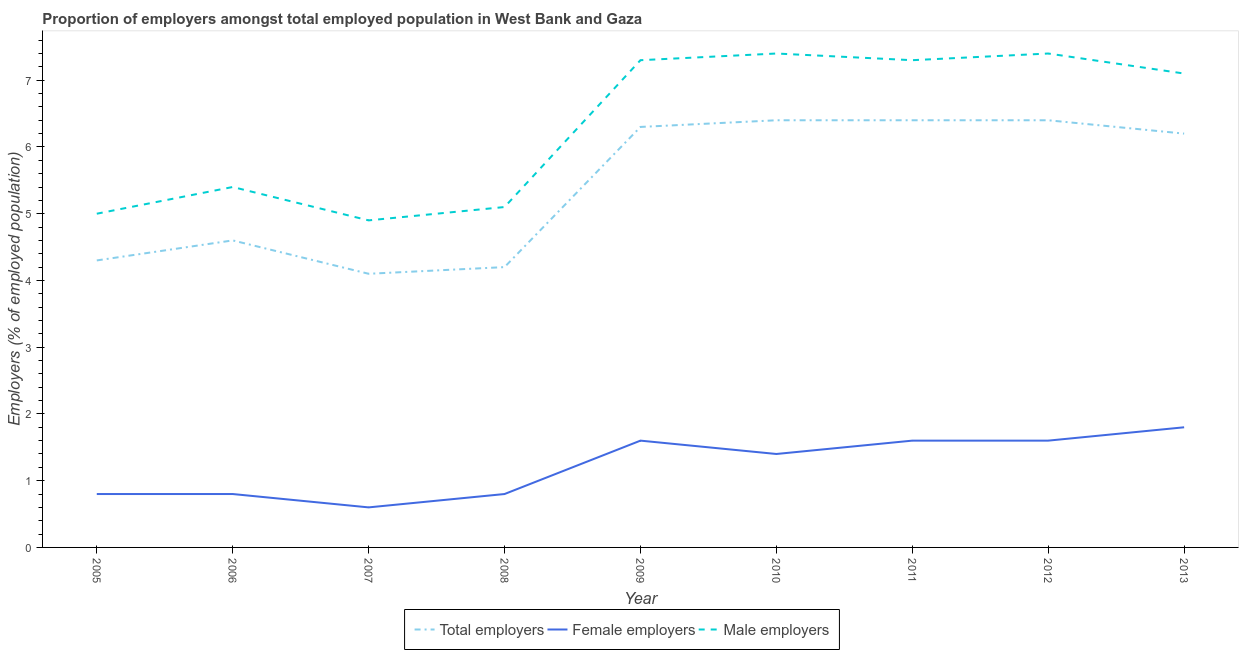Does the line corresponding to percentage of total employers intersect with the line corresponding to percentage of female employers?
Ensure brevity in your answer.  No. What is the percentage of male employers in 2005?
Keep it short and to the point. 5. Across all years, what is the maximum percentage of male employers?
Offer a terse response. 7.4. Across all years, what is the minimum percentage of female employers?
Your response must be concise. 0.6. In which year was the percentage of male employers maximum?
Ensure brevity in your answer.  2010. In which year was the percentage of female employers minimum?
Offer a terse response. 2007. What is the total percentage of male employers in the graph?
Make the answer very short. 56.9. What is the difference between the percentage of male employers in 2006 and that in 2007?
Provide a succinct answer. 0.5. What is the difference between the percentage of male employers in 2010 and the percentage of female employers in 2005?
Your response must be concise. 6.6. What is the average percentage of male employers per year?
Make the answer very short. 6.32. In the year 2011, what is the difference between the percentage of total employers and percentage of male employers?
Offer a very short reply. -0.9. In how many years, is the percentage of male employers greater than 5.8 %?
Ensure brevity in your answer.  5. What is the ratio of the percentage of female employers in 2005 to that in 2007?
Your answer should be compact. 1.33. Is the difference between the percentage of total employers in 2006 and 2011 greater than the difference between the percentage of male employers in 2006 and 2011?
Offer a very short reply. Yes. What is the difference between the highest and the lowest percentage of female employers?
Offer a terse response. 1.2. Is the sum of the percentage of total employers in 2010 and 2011 greater than the maximum percentage of female employers across all years?
Your answer should be very brief. Yes. Is it the case that in every year, the sum of the percentage of total employers and percentage of female employers is greater than the percentage of male employers?
Keep it short and to the point. No. Does the percentage of male employers monotonically increase over the years?
Keep it short and to the point. No. Is the percentage of female employers strictly less than the percentage of male employers over the years?
Give a very brief answer. Yes. How many lines are there?
Provide a succinct answer. 3. How many years are there in the graph?
Provide a short and direct response. 9. Does the graph contain grids?
Make the answer very short. No. Where does the legend appear in the graph?
Offer a very short reply. Bottom center. How are the legend labels stacked?
Ensure brevity in your answer.  Horizontal. What is the title of the graph?
Offer a very short reply. Proportion of employers amongst total employed population in West Bank and Gaza. Does "Renewable sources" appear as one of the legend labels in the graph?
Provide a short and direct response. No. What is the label or title of the Y-axis?
Your answer should be very brief. Employers (% of employed population). What is the Employers (% of employed population) of Total employers in 2005?
Keep it short and to the point. 4.3. What is the Employers (% of employed population) in Female employers in 2005?
Your response must be concise. 0.8. What is the Employers (% of employed population) in Male employers in 2005?
Ensure brevity in your answer.  5. What is the Employers (% of employed population) of Total employers in 2006?
Offer a terse response. 4.6. What is the Employers (% of employed population) in Female employers in 2006?
Your answer should be compact. 0.8. What is the Employers (% of employed population) in Male employers in 2006?
Make the answer very short. 5.4. What is the Employers (% of employed population) of Total employers in 2007?
Give a very brief answer. 4.1. What is the Employers (% of employed population) in Female employers in 2007?
Make the answer very short. 0.6. What is the Employers (% of employed population) in Male employers in 2007?
Offer a terse response. 4.9. What is the Employers (% of employed population) of Total employers in 2008?
Give a very brief answer. 4.2. What is the Employers (% of employed population) of Female employers in 2008?
Keep it short and to the point. 0.8. What is the Employers (% of employed population) of Male employers in 2008?
Your answer should be compact. 5.1. What is the Employers (% of employed population) in Total employers in 2009?
Offer a very short reply. 6.3. What is the Employers (% of employed population) of Female employers in 2009?
Your answer should be compact. 1.6. What is the Employers (% of employed population) in Male employers in 2009?
Ensure brevity in your answer.  7.3. What is the Employers (% of employed population) in Total employers in 2010?
Give a very brief answer. 6.4. What is the Employers (% of employed population) of Female employers in 2010?
Ensure brevity in your answer.  1.4. What is the Employers (% of employed population) of Male employers in 2010?
Offer a very short reply. 7.4. What is the Employers (% of employed population) in Total employers in 2011?
Your answer should be compact. 6.4. What is the Employers (% of employed population) in Female employers in 2011?
Provide a short and direct response. 1.6. What is the Employers (% of employed population) in Male employers in 2011?
Offer a terse response. 7.3. What is the Employers (% of employed population) in Total employers in 2012?
Your answer should be very brief. 6.4. What is the Employers (% of employed population) in Female employers in 2012?
Your answer should be compact. 1.6. What is the Employers (% of employed population) in Male employers in 2012?
Give a very brief answer. 7.4. What is the Employers (% of employed population) of Total employers in 2013?
Make the answer very short. 6.2. What is the Employers (% of employed population) of Female employers in 2013?
Your response must be concise. 1.8. What is the Employers (% of employed population) of Male employers in 2013?
Give a very brief answer. 7.1. Across all years, what is the maximum Employers (% of employed population) in Total employers?
Provide a succinct answer. 6.4. Across all years, what is the maximum Employers (% of employed population) in Female employers?
Ensure brevity in your answer.  1.8. Across all years, what is the maximum Employers (% of employed population) of Male employers?
Provide a succinct answer. 7.4. Across all years, what is the minimum Employers (% of employed population) in Total employers?
Keep it short and to the point. 4.1. Across all years, what is the minimum Employers (% of employed population) of Female employers?
Your response must be concise. 0.6. Across all years, what is the minimum Employers (% of employed population) of Male employers?
Provide a short and direct response. 4.9. What is the total Employers (% of employed population) in Total employers in the graph?
Provide a succinct answer. 48.9. What is the total Employers (% of employed population) in Female employers in the graph?
Give a very brief answer. 11. What is the total Employers (% of employed population) in Male employers in the graph?
Keep it short and to the point. 56.9. What is the difference between the Employers (% of employed population) of Male employers in 2005 and that in 2006?
Your answer should be very brief. -0.4. What is the difference between the Employers (% of employed population) of Male employers in 2005 and that in 2007?
Make the answer very short. 0.1. What is the difference between the Employers (% of employed population) of Total employers in 2005 and that in 2008?
Offer a very short reply. 0.1. What is the difference between the Employers (% of employed population) in Female employers in 2005 and that in 2008?
Offer a very short reply. 0. What is the difference between the Employers (% of employed population) of Total employers in 2005 and that in 2009?
Offer a very short reply. -2. What is the difference between the Employers (% of employed population) in Female employers in 2005 and that in 2009?
Keep it short and to the point. -0.8. What is the difference between the Employers (% of employed population) in Total employers in 2005 and that in 2010?
Make the answer very short. -2.1. What is the difference between the Employers (% of employed population) of Female employers in 2005 and that in 2010?
Keep it short and to the point. -0.6. What is the difference between the Employers (% of employed population) of Male employers in 2005 and that in 2010?
Provide a succinct answer. -2.4. What is the difference between the Employers (% of employed population) of Total employers in 2005 and that in 2011?
Ensure brevity in your answer.  -2.1. What is the difference between the Employers (% of employed population) of Male employers in 2005 and that in 2011?
Give a very brief answer. -2.3. What is the difference between the Employers (% of employed population) in Female employers in 2005 and that in 2012?
Offer a terse response. -0.8. What is the difference between the Employers (% of employed population) in Total employers in 2005 and that in 2013?
Provide a succinct answer. -1.9. What is the difference between the Employers (% of employed population) in Female employers in 2005 and that in 2013?
Provide a succinct answer. -1. What is the difference between the Employers (% of employed population) of Male employers in 2005 and that in 2013?
Keep it short and to the point. -2.1. What is the difference between the Employers (% of employed population) in Total employers in 2006 and that in 2007?
Keep it short and to the point. 0.5. What is the difference between the Employers (% of employed population) of Female employers in 2006 and that in 2007?
Give a very brief answer. 0.2. What is the difference between the Employers (% of employed population) of Male employers in 2006 and that in 2007?
Your response must be concise. 0.5. What is the difference between the Employers (% of employed population) in Total employers in 2006 and that in 2008?
Offer a terse response. 0.4. What is the difference between the Employers (% of employed population) of Female employers in 2006 and that in 2008?
Ensure brevity in your answer.  0. What is the difference between the Employers (% of employed population) in Total employers in 2006 and that in 2009?
Ensure brevity in your answer.  -1.7. What is the difference between the Employers (% of employed population) in Female employers in 2006 and that in 2009?
Give a very brief answer. -0.8. What is the difference between the Employers (% of employed population) in Total employers in 2006 and that in 2010?
Offer a terse response. -1.8. What is the difference between the Employers (% of employed population) of Female employers in 2006 and that in 2010?
Make the answer very short. -0.6. What is the difference between the Employers (% of employed population) in Male employers in 2006 and that in 2010?
Keep it short and to the point. -2. What is the difference between the Employers (% of employed population) of Total employers in 2006 and that in 2011?
Offer a very short reply. -1.8. What is the difference between the Employers (% of employed population) in Male employers in 2006 and that in 2011?
Provide a succinct answer. -1.9. What is the difference between the Employers (% of employed population) in Female employers in 2006 and that in 2012?
Ensure brevity in your answer.  -0.8. What is the difference between the Employers (% of employed population) of Male employers in 2006 and that in 2012?
Give a very brief answer. -2. What is the difference between the Employers (% of employed population) in Male employers in 2006 and that in 2013?
Give a very brief answer. -1.7. What is the difference between the Employers (% of employed population) in Total employers in 2007 and that in 2008?
Your answer should be compact. -0.1. What is the difference between the Employers (% of employed population) of Female employers in 2007 and that in 2008?
Your answer should be very brief. -0.2. What is the difference between the Employers (% of employed population) in Male employers in 2007 and that in 2008?
Your answer should be very brief. -0.2. What is the difference between the Employers (% of employed population) in Total employers in 2007 and that in 2009?
Give a very brief answer. -2.2. What is the difference between the Employers (% of employed population) in Total employers in 2007 and that in 2010?
Give a very brief answer. -2.3. What is the difference between the Employers (% of employed population) of Total employers in 2007 and that in 2012?
Offer a very short reply. -2.3. What is the difference between the Employers (% of employed population) of Female employers in 2007 and that in 2012?
Provide a short and direct response. -1. What is the difference between the Employers (% of employed population) in Total employers in 2008 and that in 2009?
Make the answer very short. -2.1. What is the difference between the Employers (% of employed population) in Female employers in 2008 and that in 2009?
Provide a succinct answer. -0.8. What is the difference between the Employers (% of employed population) of Male employers in 2008 and that in 2010?
Offer a terse response. -2.3. What is the difference between the Employers (% of employed population) in Total employers in 2008 and that in 2011?
Provide a succinct answer. -2.2. What is the difference between the Employers (% of employed population) in Female employers in 2008 and that in 2011?
Your answer should be compact. -0.8. What is the difference between the Employers (% of employed population) in Male employers in 2008 and that in 2011?
Offer a terse response. -2.2. What is the difference between the Employers (% of employed population) of Total employers in 2008 and that in 2012?
Give a very brief answer. -2.2. What is the difference between the Employers (% of employed population) in Female employers in 2008 and that in 2012?
Provide a succinct answer. -0.8. What is the difference between the Employers (% of employed population) of Female employers in 2008 and that in 2013?
Make the answer very short. -1. What is the difference between the Employers (% of employed population) in Total employers in 2009 and that in 2010?
Give a very brief answer. -0.1. What is the difference between the Employers (% of employed population) in Female employers in 2009 and that in 2011?
Your response must be concise. 0. What is the difference between the Employers (% of employed population) in Male employers in 2009 and that in 2011?
Make the answer very short. 0. What is the difference between the Employers (% of employed population) in Total employers in 2009 and that in 2012?
Your answer should be very brief. -0.1. What is the difference between the Employers (% of employed population) of Male employers in 2009 and that in 2012?
Your response must be concise. -0.1. What is the difference between the Employers (% of employed population) in Female employers in 2009 and that in 2013?
Provide a succinct answer. -0.2. What is the difference between the Employers (% of employed population) in Male employers in 2009 and that in 2013?
Ensure brevity in your answer.  0.2. What is the difference between the Employers (% of employed population) in Female employers in 2010 and that in 2011?
Ensure brevity in your answer.  -0.2. What is the difference between the Employers (% of employed population) of Total employers in 2010 and that in 2012?
Offer a very short reply. 0. What is the difference between the Employers (% of employed population) of Total employers in 2010 and that in 2013?
Give a very brief answer. 0.2. What is the difference between the Employers (% of employed population) of Female employers in 2010 and that in 2013?
Make the answer very short. -0.4. What is the difference between the Employers (% of employed population) in Male employers in 2011 and that in 2012?
Your response must be concise. -0.1. What is the difference between the Employers (% of employed population) in Female employers in 2011 and that in 2013?
Your answer should be compact. -0.2. What is the difference between the Employers (% of employed population) of Female employers in 2012 and that in 2013?
Offer a terse response. -0.2. What is the difference between the Employers (% of employed population) of Male employers in 2012 and that in 2013?
Offer a terse response. 0.3. What is the difference between the Employers (% of employed population) of Female employers in 2005 and the Employers (% of employed population) of Male employers in 2006?
Give a very brief answer. -4.6. What is the difference between the Employers (% of employed population) in Total employers in 2005 and the Employers (% of employed population) in Female employers in 2007?
Offer a terse response. 3.7. What is the difference between the Employers (% of employed population) of Total employers in 2005 and the Employers (% of employed population) of Female employers in 2008?
Your answer should be compact. 3.5. What is the difference between the Employers (% of employed population) in Total employers in 2005 and the Employers (% of employed population) in Male employers in 2008?
Your answer should be compact. -0.8. What is the difference between the Employers (% of employed population) in Female employers in 2005 and the Employers (% of employed population) in Male employers in 2008?
Ensure brevity in your answer.  -4.3. What is the difference between the Employers (% of employed population) of Female employers in 2005 and the Employers (% of employed population) of Male employers in 2009?
Your answer should be compact. -6.5. What is the difference between the Employers (% of employed population) in Total employers in 2005 and the Employers (% of employed population) in Female employers in 2010?
Give a very brief answer. 2.9. What is the difference between the Employers (% of employed population) of Total employers in 2005 and the Employers (% of employed population) of Female employers in 2011?
Ensure brevity in your answer.  2.7. What is the difference between the Employers (% of employed population) in Total employers in 2005 and the Employers (% of employed population) in Male employers in 2011?
Provide a short and direct response. -3. What is the difference between the Employers (% of employed population) of Total employers in 2005 and the Employers (% of employed population) of Male employers in 2012?
Offer a very short reply. -3.1. What is the difference between the Employers (% of employed population) of Total employers in 2005 and the Employers (% of employed population) of Female employers in 2013?
Provide a short and direct response. 2.5. What is the difference between the Employers (% of employed population) in Total employers in 2006 and the Employers (% of employed population) in Female employers in 2007?
Make the answer very short. 4. What is the difference between the Employers (% of employed population) in Total employers in 2006 and the Employers (% of employed population) in Male employers in 2008?
Ensure brevity in your answer.  -0.5. What is the difference between the Employers (% of employed population) in Female employers in 2006 and the Employers (% of employed population) in Male employers in 2009?
Your response must be concise. -6.5. What is the difference between the Employers (% of employed population) of Total employers in 2006 and the Employers (% of employed population) of Female employers in 2011?
Give a very brief answer. 3. What is the difference between the Employers (% of employed population) in Total employers in 2006 and the Employers (% of employed population) in Female employers in 2012?
Offer a very short reply. 3. What is the difference between the Employers (% of employed population) in Female employers in 2006 and the Employers (% of employed population) in Male employers in 2012?
Give a very brief answer. -6.6. What is the difference between the Employers (% of employed population) of Total employers in 2006 and the Employers (% of employed population) of Female employers in 2013?
Give a very brief answer. 2.8. What is the difference between the Employers (% of employed population) of Total employers in 2006 and the Employers (% of employed population) of Male employers in 2013?
Offer a very short reply. -2.5. What is the difference between the Employers (% of employed population) of Female employers in 2006 and the Employers (% of employed population) of Male employers in 2013?
Keep it short and to the point. -6.3. What is the difference between the Employers (% of employed population) of Total employers in 2007 and the Employers (% of employed population) of Male employers in 2008?
Make the answer very short. -1. What is the difference between the Employers (% of employed population) in Total employers in 2007 and the Employers (% of employed population) in Male employers in 2009?
Give a very brief answer. -3.2. What is the difference between the Employers (% of employed population) of Female employers in 2007 and the Employers (% of employed population) of Male employers in 2009?
Offer a very short reply. -6.7. What is the difference between the Employers (% of employed population) of Total employers in 2007 and the Employers (% of employed population) of Male employers in 2010?
Provide a short and direct response. -3.3. What is the difference between the Employers (% of employed population) of Total employers in 2007 and the Employers (% of employed population) of Female employers in 2011?
Keep it short and to the point. 2.5. What is the difference between the Employers (% of employed population) in Total employers in 2007 and the Employers (% of employed population) in Male employers in 2011?
Your answer should be very brief. -3.2. What is the difference between the Employers (% of employed population) of Female employers in 2007 and the Employers (% of employed population) of Male employers in 2011?
Provide a short and direct response. -6.7. What is the difference between the Employers (% of employed population) in Total employers in 2007 and the Employers (% of employed population) in Male employers in 2012?
Provide a succinct answer. -3.3. What is the difference between the Employers (% of employed population) in Female employers in 2007 and the Employers (% of employed population) in Male employers in 2012?
Offer a very short reply. -6.8. What is the difference between the Employers (% of employed population) in Total employers in 2007 and the Employers (% of employed population) in Female employers in 2013?
Your answer should be very brief. 2.3. What is the difference between the Employers (% of employed population) in Total employers in 2007 and the Employers (% of employed population) in Male employers in 2013?
Ensure brevity in your answer.  -3. What is the difference between the Employers (% of employed population) of Female employers in 2007 and the Employers (% of employed population) of Male employers in 2013?
Provide a succinct answer. -6.5. What is the difference between the Employers (% of employed population) of Total employers in 2008 and the Employers (% of employed population) of Male employers in 2009?
Give a very brief answer. -3.1. What is the difference between the Employers (% of employed population) of Female employers in 2008 and the Employers (% of employed population) of Male employers in 2009?
Keep it short and to the point. -6.5. What is the difference between the Employers (% of employed population) in Female employers in 2008 and the Employers (% of employed population) in Male employers in 2010?
Keep it short and to the point. -6.6. What is the difference between the Employers (% of employed population) in Total employers in 2008 and the Employers (% of employed population) in Female employers in 2011?
Ensure brevity in your answer.  2.6. What is the difference between the Employers (% of employed population) in Female employers in 2008 and the Employers (% of employed population) in Male employers in 2011?
Give a very brief answer. -6.5. What is the difference between the Employers (% of employed population) in Total employers in 2008 and the Employers (% of employed population) in Female employers in 2012?
Make the answer very short. 2.6. What is the difference between the Employers (% of employed population) of Female employers in 2008 and the Employers (% of employed population) of Male employers in 2013?
Provide a short and direct response. -6.3. What is the difference between the Employers (% of employed population) of Total employers in 2009 and the Employers (% of employed population) of Male employers in 2010?
Keep it short and to the point. -1.1. What is the difference between the Employers (% of employed population) in Female employers in 2009 and the Employers (% of employed population) in Male employers in 2010?
Give a very brief answer. -5.8. What is the difference between the Employers (% of employed population) in Total employers in 2009 and the Employers (% of employed population) in Female employers in 2011?
Give a very brief answer. 4.7. What is the difference between the Employers (% of employed population) in Total employers in 2009 and the Employers (% of employed population) in Female employers in 2012?
Your answer should be very brief. 4.7. What is the difference between the Employers (% of employed population) of Total employers in 2009 and the Employers (% of employed population) of Male employers in 2012?
Offer a terse response. -1.1. What is the difference between the Employers (% of employed population) of Total employers in 2009 and the Employers (% of employed population) of Female employers in 2013?
Provide a short and direct response. 4.5. What is the difference between the Employers (% of employed population) in Total employers in 2010 and the Employers (% of employed population) in Male employers in 2011?
Your answer should be very brief. -0.9. What is the difference between the Employers (% of employed population) of Female employers in 2010 and the Employers (% of employed population) of Male employers in 2011?
Keep it short and to the point. -5.9. What is the difference between the Employers (% of employed population) of Total employers in 2011 and the Employers (% of employed population) of Male employers in 2013?
Offer a very short reply. -0.7. What is the difference between the Employers (% of employed population) of Female employers in 2011 and the Employers (% of employed population) of Male employers in 2013?
Give a very brief answer. -5.5. What is the difference between the Employers (% of employed population) of Total employers in 2012 and the Employers (% of employed population) of Female employers in 2013?
Give a very brief answer. 4.6. What is the average Employers (% of employed population) of Total employers per year?
Provide a succinct answer. 5.43. What is the average Employers (% of employed population) in Female employers per year?
Keep it short and to the point. 1.22. What is the average Employers (% of employed population) in Male employers per year?
Your answer should be very brief. 6.32. In the year 2005, what is the difference between the Employers (% of employed population) of Total employers and Employers (% of employed population) of Female employers?
Your response must be concise. 3.5. In the year 2005, what is the difference between the Employers (% of employed population) of Female employers and Employers (% of employed population) of Male employers?
Your answer should be compact. -4.2. In the year 2006, what is the difference between the Employers (% of employed population) in Total employers and Employers (% of employed population) in Female employers?
Ensure brevity in your answer.  3.8. In the year 2007, what is the difference between the Employers (% of employed population) in Total employers and Employers (% of employed population) in Female employers?
Make the answer very short. 3.5. In the year 2007, what is the difference between the Employers (% of employed population) in Total employers and Employers (% of employed population) in Male employers?
Your answer should be compact. -0.8. In the year 2008, what is the difference between the Employers (% of employed population) of Total employers and Employers (% of employed population) of Male employers?
Offer a very short reply. -0.9. In the year 2008, what is the difference between the Employers (% of employed population) of Female employers and Employers (% of employed population) of Male employers?
Give a very brief answer. -4.3. In the year 2009, what is the difference between the Employers (% of employed population) of Total employers and Employers (% of employed population) of Male employers?
Your answer should be very brief. -1. In the year 2010, what is the difference between the Employers (% of employed population) in Total employers and Employers (% of employed population) in Female employers?
Offer a very short reply. 5. In the year 2010, what is the difference between the Employers (% of employed population) in Total employers and Employers (% of employed population) in Male employers?
Your answer should be compact. -1. In the year 2011, what is the difference between the Employers (% of employed population) of Total employers and Employers (% of employed population) of Male employers?
Offer a terse response. -0.9. In the year 2012, what is the difference between the Employers (% of employed population) of Total employers and Employers (% of employed population) of Male employers?
Your answer should be compact. -1. In the year 2012, what is the difference between the Employers (% of employed population) in Female employers and Employers (% of employed population) in Male employers?
Make the answer very short. -5.8. What is the ratio of the Employers (% of employed population) of Total employers in 2005 to that in 2006?
Keep it short and to the point. 0.93. What is the ratio of the Employers (% of employed population) in Female employers in 2005 to that in 2006?
Offer a terse response. 1. What is the ratio of the Employers (% of employed population) in Male employers in 2005 to that in 2006?
Provide a succinct answer. 0.93. What is the ratio of the Employers (% of employed population) in Total employers in 2005 to that in 2007?
Your response must be concise. 1.05. What is the ratio of the Employers (% of employed population) of Male employers in 2005 to that in 2007?
Keep it short and to the point. 1.02. What is the ratio of the Employers (% of employed population) of Total employers in 2005 to that in 2008?
Give a very brief answer. 1.02. What is the ratio of the Employers (% of employed population) in Female employers in 2005 to that in 2008?
Offer a very short reply. 1. What is the ratio of the Employers (% of employed population) of Male employers in 2005 to that in 2008?
Ensure brevity in your answer.  0.98. What is the ratio of the Employers (% of employed population) of Total employers in 2005 to that in 2009?
Ensure brevity in your answer.  0.68. What is the ratio of the Employers (% of employed population) in Male employers in 2005 to that in 2009?
Ensure brevity in your answer.  0.68. What is the ratio of the Employers (% of employed population) in Total employers in 2005 to that in 2010?
Ensure brevity in your answer.  0.67. What is the ratio of the Employers (% of employed population) in Male employers in 2005 to that in 2010?
Your response must be concise. 0.68. What is the ratio of the Employers (% of employed population) of Total employers in 2005 to that in 2011?
Your response must be concise. 0.67. What is the ratio of the Employers (% of employed population) in Female employers in 2005 to that in 2011?
Provide a short and direct response. 0.5. What is the ratio of the Employers (% of employed population) in Male employers in 2005 to that in 2011?
Keep it short and to the point. 0.68. What is the ratio of the Employers (% of employed population) of Total employers in 2005 to that in 2012?
Ensure brevity in your answer.  0.67. What is the ratio of the Employers (% of employed population) in Male employers in 2005 to that in 2012?
Keep it short and to the point. 0.68. What is the ratio of the Employers (% of employed population) of Total employers in 2005 to that in 2013?
Offer a very short reply. 0.69. What is the ratio of the Employers (% of employed population) in Female employers in 2005 to that in 2013?
Your response must be concise. 0.44. What is the ratio of the Employers (% of employed population) of Male employers in 2005 to that in 2013?
Offer a terse response. 0.7. What is the ratio of the Employers (% of employed population) of Total employers in 2006 to that in 2007?
Give a very brief answer. 1.12. What is the ratio of the Employers (% of employed population) of Female employers in 2006 to that in 2007?
Offer a very short reply. 1.33. What is the ratio of the Employers (% of employed population) in Male employers in 2006 to that in 2007?
Ensure brevity in your answer.  1.1. What is the ratio of the Employers (% of employed population) of Total employers in 2006 to that in 2008?
Provide a short and direct response. 1.1. What is the ratio of the Employers (% of employed population) of Female employers in 2006 to that in 2008?
Your answer should be very brief. 1. What is the ratio of the Employers (% of employed population) of Male employers in 2006 to that in 2008?
Make the answer very short. 1.06. What is the ratio of the Employers (% of employed population) of Total employers in 2006 to that in 2009?
Make the answer very short. 0.73. What is the ratio of the Employers (% of employed population) in Female employers in 2006 to that in 2009?
Provide a short and direct response. 0.5. What is the ratio of the Employers (% of employed population) of Male employers in 2006 to that in 2009?
Your answer should be compact. 0.74. What is the ratio of the Employers (% of employed population) in Total employers in 2006 to that in 2010?
Make the answer very short. 0.72. What is the ratio of the Employers (% of employed population) of Female employers in 2006 to that in 2010?
Your answer should be compact. 0.57. What is the ratio of the Employers (% of employed population) of Male employers in 2006 to that in 2010?
Ensure brevity in your answer.  0.73. What is the ratio of the Employers (% of employed population) in Total employers in 2006 to that in 2011?
Provide a succinct answer. 0.72. What is the ratio of the Employers (% of employed population) in Female employers in 2006 to that in 2011?
Ensure brevity in your answer.  0.5. What is the ratio of the Employers (% of employed population) of Male employers in 2006 to that in 2011?
Provide a succinct answer. 0.74. What is the ratio of the Employers (% of employed population) of Total employers in 2006 to that in 2012?
Give a very brief answer. 0.72. What is the ratio of the Employers (% of employed population) of Female employers in 2006 to that in 2012?
Provide a succinct answer. 0.5. What is the ratio of the Employers (% of employed population) in Male employers in 2006 to that in 2012?
Offer a very short reply. 0.73. What is the ratio of the Employers (% of employed population) of Total employers in 2006 to that in 2013?
Your answer should be compact. 0.74. What is the ratio of the Employers (% of employed population) in Female employers in 2006 to that in 2013?
Make the answer very short. 0.44. What is the ratio of the Employers (% of employed population) in Male employers in 2006 to that in 2013?
Your answer should be very brief. 0.76. What is the ratio of the Employers (% of employed population) in Total employers in 2007 to that in 2008?
Your response must be concise. 0.98. What is the ratio of the Employers (% of employed population) in Male employers in 2007 to that in 2008?
Offer a terse response. 0.96. What is the ratio of the Employers (% of employed population) in Total employers in 2007 to that in 2009?
Provide a succinct answer. 0.65. What is the ratio of the Employers (% of employed population) in Male employers in 2007 to that in 2009?
Offer a terse response. 0.67. What is the ratio of the Employers (% of employed population) in Total employers in 2007 to that in 2010?
Provide a succinct answer. 0.64. What is the ratio of the Employers (% of employed population) in Female employers in 2007 to that in 2010?
Keep it short and to the point. 0.43. What is the ratio of the Employers (% of employed population) in Male employers in 2007 to that in 2010?
Offer a very short reply. 0.66. What is the ratio of the Employers (% of employed population) of Total employers in 2007 to that in 2011?
Offer a terse response. 0.64. What is the ratio of the Employers (% of employed population) of Male employers in 2007 to that in 2011?
Your answer should be compact. 0.67. What is the ratio of the Employers (% of employed population) of Total employers in 2007 to that in 2012?
Offer a very short reply. 0.64. What is the ratio of the Employers (% of employed population) in Female employers in 2007 to that in 2012?
Offer a very short reply. 0.38. What is the ratio of the Employers (% of employed population) of Male employers in 2007 to that in 2012?
Provide a short and direct response. 0.66. What is the ratio of the Employers (% of employed population) in Total employers in 2007 to that in 2013?
Keep it short and to the point. 0.66. What is the ratio of the Employers (% of employed population) in Female employers in 2007 to that in 2013?
Your answer should be very brief. 0.33. What is the ratio of the Employers (% of employed population) in Male employers in 2007 to that in 2013?
Your answer should be compact. 0.69. What is the ratio of the Employers (% of employed population) of Female employers in 2008 to that in 2009?
Your answer should be compact. 0.5. What is the ratio of the Employers (% of employed population) of Male employers in 2008 to that in 2009?
Your answer should be very brief. 0.7. What is the ratio of the Employers (% of employed population) of Total employers in 2008 to that in 2010?
Your response must be concise. 0.66. What is the ratio of the Employers (% of employed population) in Male employers in 2008 to that in 2010?
Your answer should be very brief. 0.69. What is the ratio of the Employers (% of employed population) of Total employers in 2008 to that in 2011?
Your answer should be compact. 0.66. What is the ratio of the Employers (% of employed population) in Male employers in 2008 to that in 2011?
Your answer should be very brief. 0.7. What is the ratio of the Employers (% of employed population) of Total employers in 2008 to that in 2012?
Your answer should be compact. 0.66. What is the ratio of the Employers (% of employed population) of Male employers in 2008 to that in 2012?
Your answer should be very brief. 0.69. What is the ratio of the Employers (% of employed population) in Total employers in 2008 to that in 2013?
Offer a terse response. 0.68. What is the ratio of the Employers (% of employed population) in Female employers in 2008 to that in 2013?
Keep it short and to the point. 0.44. What is the ratio of the Employers (% of employed population) of Male employers in 2008 to that in 2013?
Make the answer very short. 0.72. What is the ratio of the Employers (% of employed population) of Total employers in 2009 to that in 2010?
Your response must be concise. 0.98. What is the ratio of the Employers (% of employed population) in Female employers in 2009 to that in 2010?
Provide a short and direct response. 1.14. What is the ratio of the Employers (% of employed population) of Male employers in 2009 to that in 2010?
Your response must be concise. 0.99. What is the ratio of the Employers (% of employed population) in Total employers in 2009 to that in 2011?
Give a very brief answer. 0.98. What is the ratio of the Employers (% of employed population) in Total employers in 2009 to that in 2012?
Provide a short and direct response. 0.98. What is the ratio of the Employers (% of employed population) of Male employers in 2009 to that in 2012?
Give a very brief answer. 0.99. What is the ratio of the Employers (% of employed population) in Total employers in 2009 to that in 2013?
Offer a terse response. 1.02. What is the ratio of the Employers (% of employed population) in Female employers in 2009 to that in 2013?
Your answer should be very brief. 0.89. What is the ratio of the Employers (% of employed population) in Male employers in 2009 to that in 2013?
Offer a very short reply. 1.03. What is the ratio of the Employers (% of employed population) of Female employers in 2010 to that in 2011?
Your answer should be compact. 0.88. What is the ratio of the Employers (% of employed population) in Male employers in 2010 to that in 2011?
Your answer should be very brief. 1.01. What is the ratio of the Employers (% of employed population) in Total employers in 2010 to that in 2012?
Your response must be concise. 1. What is the ratio of the Employers (% of employed population) of Male employers in 2010 to that in 2012?
Provide a succinct answer. 1. What is the ratio of the Employers (% of employed population) of Total employers in 2010 to that in 2013?
Offer a terse response. 1.03. What is the ratio of the Employers (% of employed population) of Male employers in 2010 to that in 2013?
Ensure brevity in your answer.  1.04. What is the ratio of the Employers (% of employed population) of Total employers in 2011 to that in 2012?
Offer a very short reply. 1. What is the ratio of the Employers (% of employed population) of Female employers in 2011 to that in 2012?
Make the answer very short. 1. What is the ratio of the Employers (% of employed population) of Male employers in 2011 to that in 2012?
Provide a succinct answer. 0.99. What is the ratio of the Employers (% of employed population) in Total employers in 2011 to that in 2013?
Ensure brevity in your answer.  1.03. What is the ratio of the Employers (% of employed population) of Female employers in 2011 to that in 2013?
Offer a very short reply. 0.89. What is the ratio of the Employers (% of employed population) of Male employers in 2011 to that in 2013?
Offer a very short reply. 1.03. What is the ratio of the Employers (% of employed population) in Total employers in 2012 to that in 2013?
Offer a very short reply. 1.03. What is the ratio of the Employers (% of employed population) of Female employers in 2012 to that in 2013?
Ensure brevity in your answer.  0.89. What is the ratio of the Employers (% of employed population) of Male employers in 2012 to that in 2013?
Your answer should be compact. 1.04. What is the difference between the highest and the lowest Employers (% of employed population) in Female employers?
Your answer should be very brief. 1.2. What is the difference between the highest and the lowest Employers (% of employed population) in Male employers?
Offer a terse response. 2.5. 